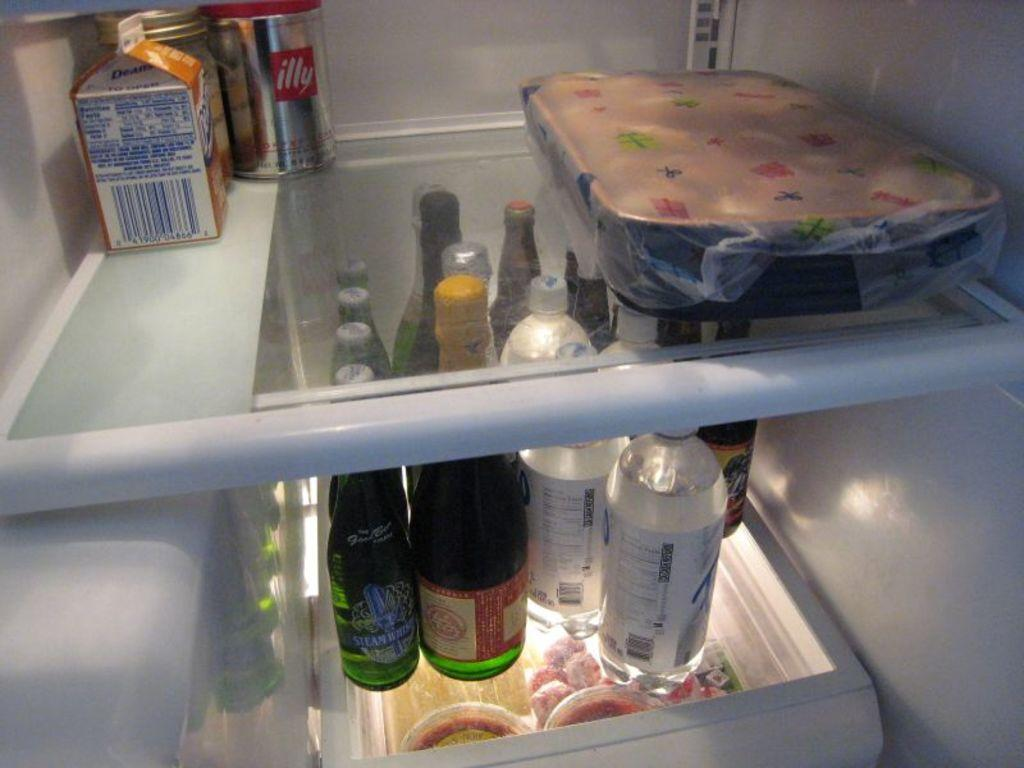<image>
Describe the image concisely. A can of illy sits in the very back of the fridge. 